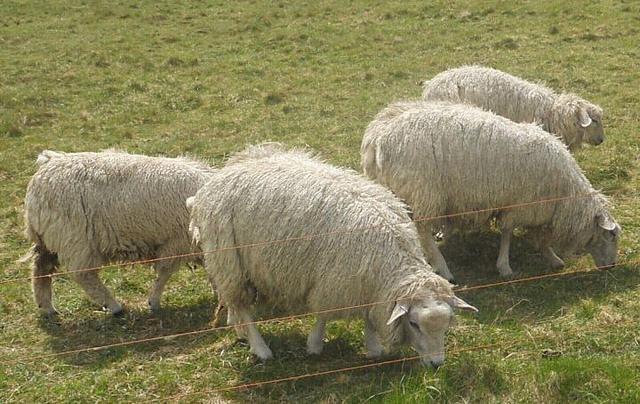How many sheep?
Give a very brief answer. 4. How many sheep are visible?
Give a very brief answer. 4. 